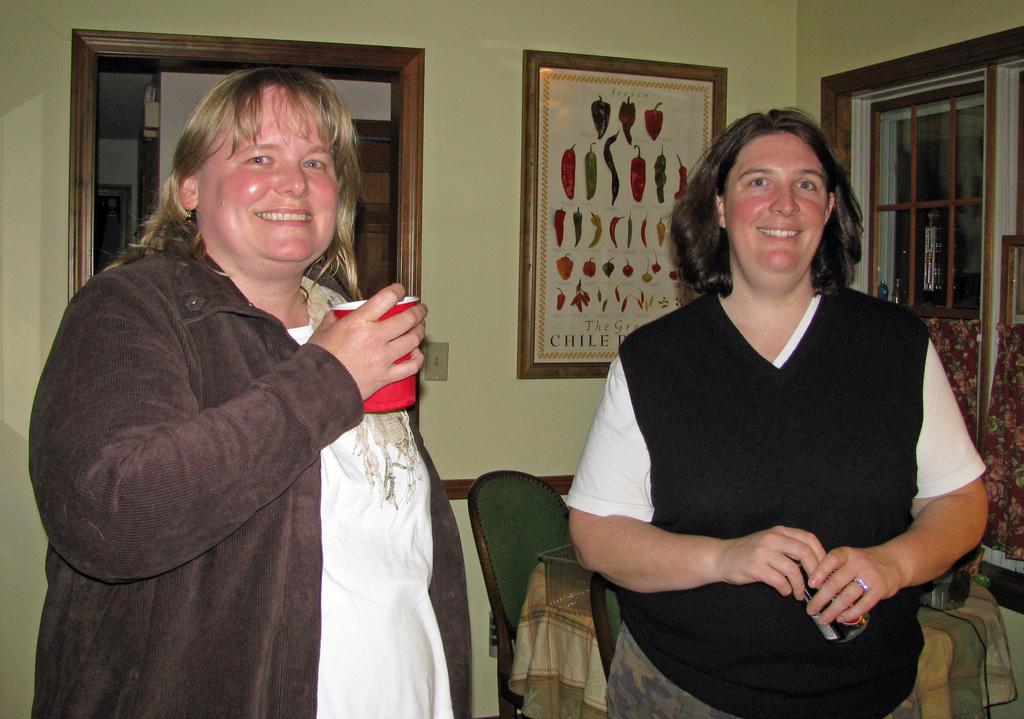How many people are in the image? There are two persons standing in the image. What is the facial expression of the persons? The persons are smiling. What can be seen in the background of the image? There is a wall in the background of the image. What is on the wall in the image? There is a photo frame on the wall. What architectural features are present in the image? There is a window and a door in the image. What type of polish is being applied to the kitten in the image? There is no kitten or polish present in the image. How many ice cubes are visible in the image? There is no ice or ice cubes visible in the image. 